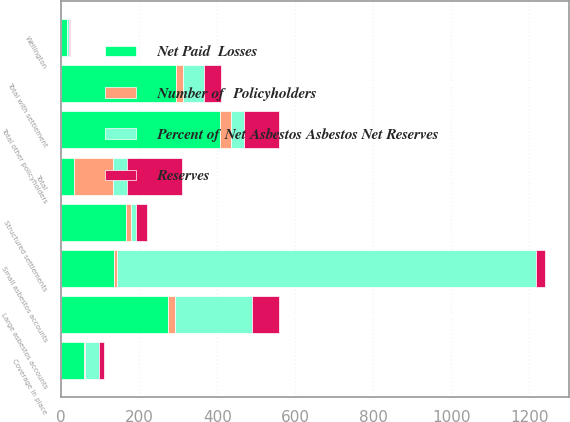<chart> <loc_0><loc_0><loc_500><loc_500><stacked_bar_chart><ecel><fcel>Structured settlements<fcel>Wellington<fcel>Coverage in place<fcel>Total with settlement<fcel>Large asbestos accounts<fcel>Small asbestos accounts<fcel>Total other policyholders<fcel>Total<nl><fcel>Percent of Net Asbestos Asbestos Net Reserves<fcel>13<fcel>4<fcel>34<fcel>52<fcel>199<fcel>1073<fcel>34<fcel>34<nl><fcel>Reserves<fcel>30<fcel>2<fcel>13<fcel>45<fcel>68<fcel>23<fcel>91<fcel>142<nl><fcel>Net Paid  Losses<fcel>167<fcel>15<fcel>58<fcel>294<fcel>273<fcel>135<fcel>408<fcel>34<nl><fcel>Number of  Policyholders<fcel>10.7<fcel>1<fcel>3.7<fcel>18.9<fcel>17.6<fcel>8.7<fcel>26.3<fcel>100<nl></chart> 